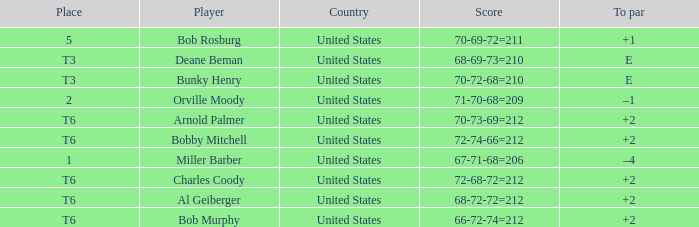What is the position of the 68-69-73=210? T3. 